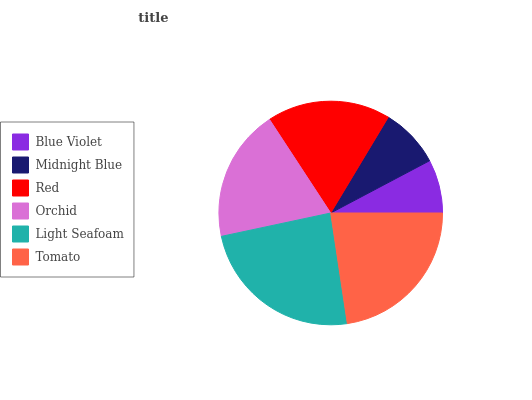Is Blue Violet the minimum?
Answer yes or no. Yes. Is Light Seafoam the maximum?
Answer yes or no. Yes. Is Midnight Blue the minimum?
Answer yes or no. No. Is Midnight Blue the maximum?
Answer yes or no. No. Is Midnight Blue greater than Blue Violet?
Answer yes or no. Yes. Is Blue Violet less than Midnight Blue?
Answer yes or no. Yes. Is Blue Violet greater than Midnight Blue?
Answer yes or no. No. Is Midnight Blue less than Blue Violet?
Answer yes or no. No. Is Orchid the high median?
Answer yes or no. Yes. Is Red the low median?
Answer yes or no. Yes. Is Red the high median?
Answer yes or no. No. Is Tomato the low median?
Answer yes or no. No. 